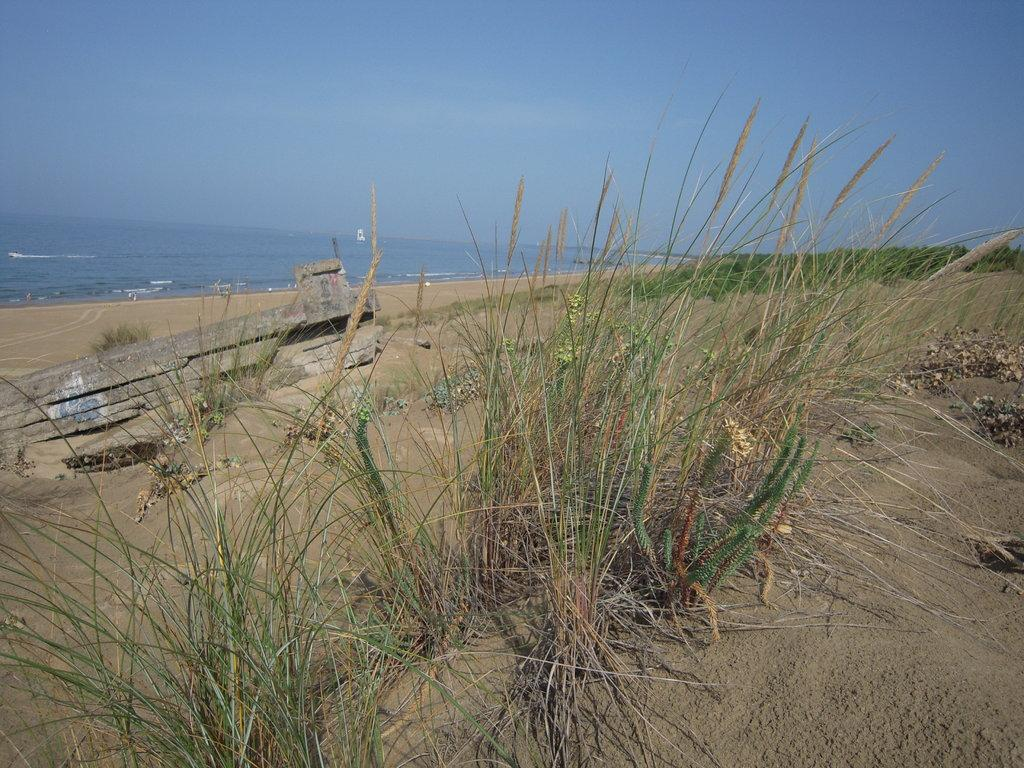What type of vegetation is in the center of the image? There is grass in the center of the image. What material is used for the objects on the left side of the image? There are wooden boards on the left side of the image. What can be seen in the background of the image? Water and the sky are visible in the background of the image. Where is the store located in the image? There is no store present in the image. How many cats can be seen playing with the wooden boards in the image? There are no cats present in the image. 